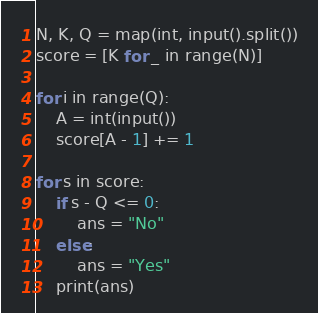<code> <loc_0><loc_0><loc_500><loc_500><_Python_>N, K, Q = map(int, input().split())
score = [K for _ in range(N)]

for i in range(Q):
    A = int(input())
    score[A - 1] += 1

for s in score:
    if s - Q <= 0:
        ans = "No"
    else:
        ans = "Yes"
    print(ans)
</code> 